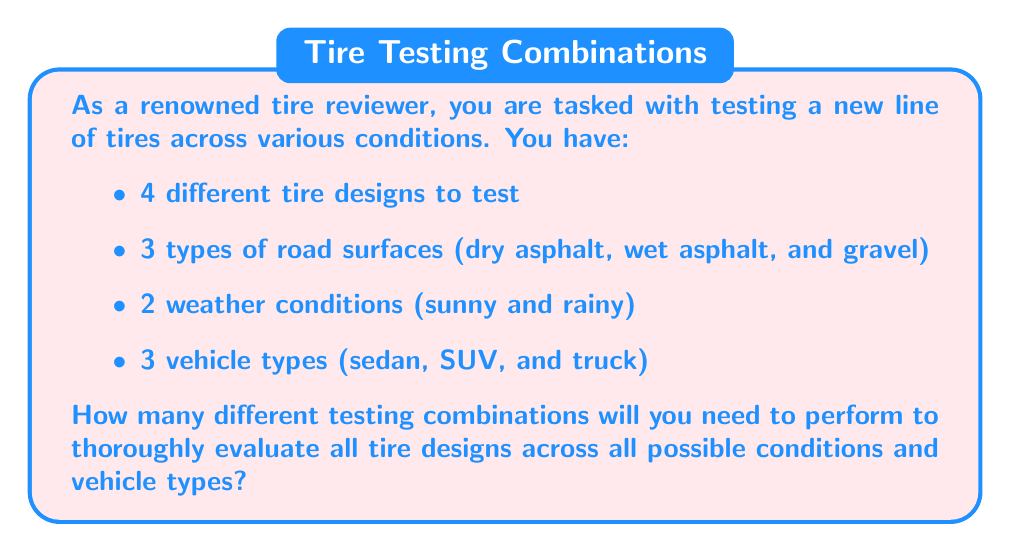Could you help me with this problem? To solve this problem, we need to apply the multiplication principle of counting. This principle states that if we have multiple independent choices, the total number of possible outcomes is the product of the number of choices for each decision.

Let's break down the given information:
1. Number of tire designs: 4
2. Number of road surfaces: 3
3. Number of weather conditions: 2
4. Number of vehicle types: 3

For each tire design, we need to test it on each road surface, in each weather condition, and with each vehicle type. This creates a combination of choices.

The total number of combinations can be calculated as follows:

$$ \text{Total combinations} = \text{Tire designs} \times \text{Road surfaces} \times \text{Weather conditions} \times \text{Vehicle types} $$

Substituting the values:

$$ \text{Total combinations} = 4 \times 3 \times 2 \times 3 $$

Now, let's multiply these numbers:

$$ \text{Total combinations} = 4 \times 3 \times 2 \times 3 = 72 $$

Therefore, you will need to perform 72 different testing combinations to thoroughly evaluate all tire designs across all possible conditions and vehicle types.
Answer: 72 testing combinations 